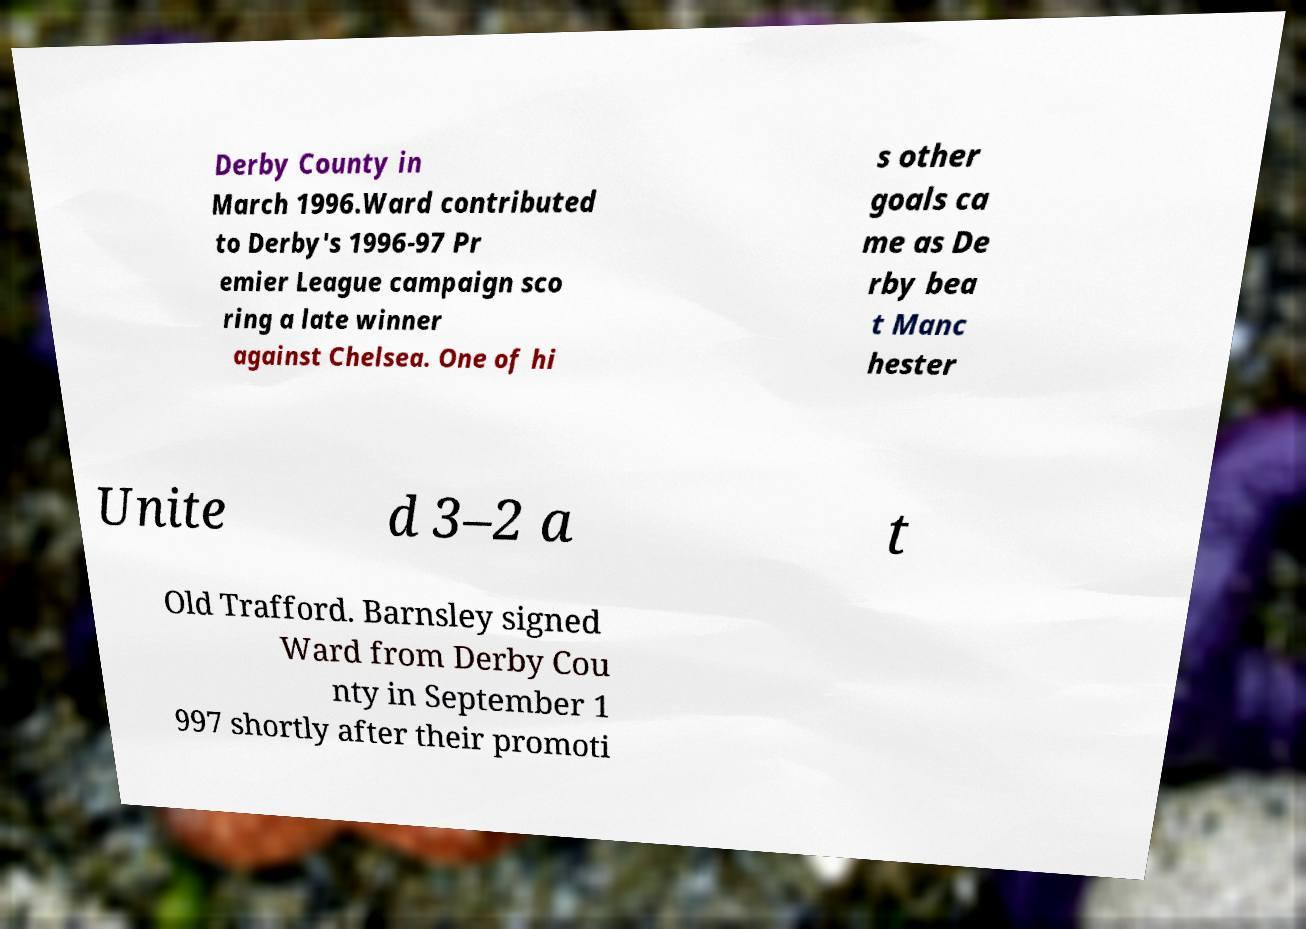There's text embedded in this image that I need extracted. Can you transcribe it verbatim? Derby County in March 1996.Ward contributed to Derby's 1996-97 Pr emier League campaign sco ring a late winner against Chelsea. One of hi s other goals ca me as De rby bea t Manc hester Unite d 3–2 a t Old Trafford. Barnsley signed Ward from Derby Cou nty in September 1 997 shortly after their promoti 